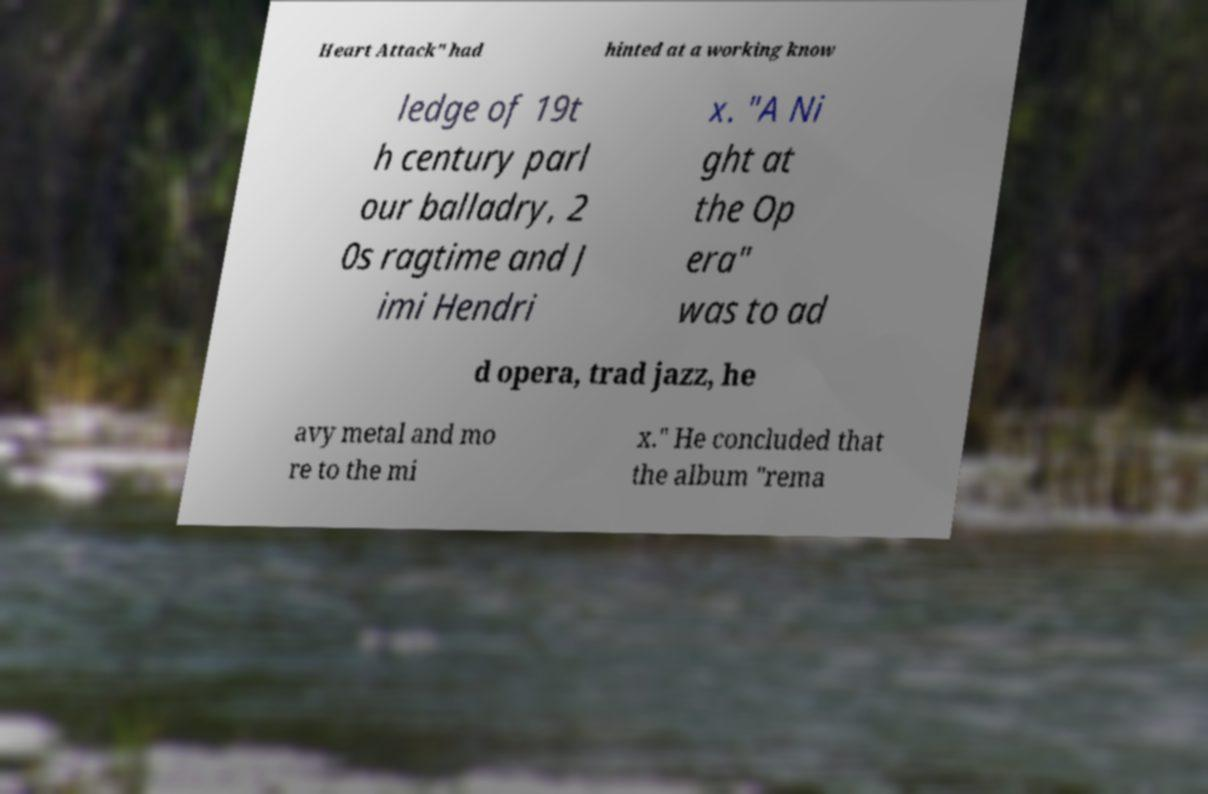For documentation purposes, I need the text within this image transcribed. Could you provide that? Heart Attack" had hinted at a working know ledge of 19t h century parl our balladry, 2 0s ragtime and J imi Hendri x. "A Ni ght at the Op era" was to ad d opera, trad jazz, he avy metal and mo re to the mi x." He concluded that the album "rema 